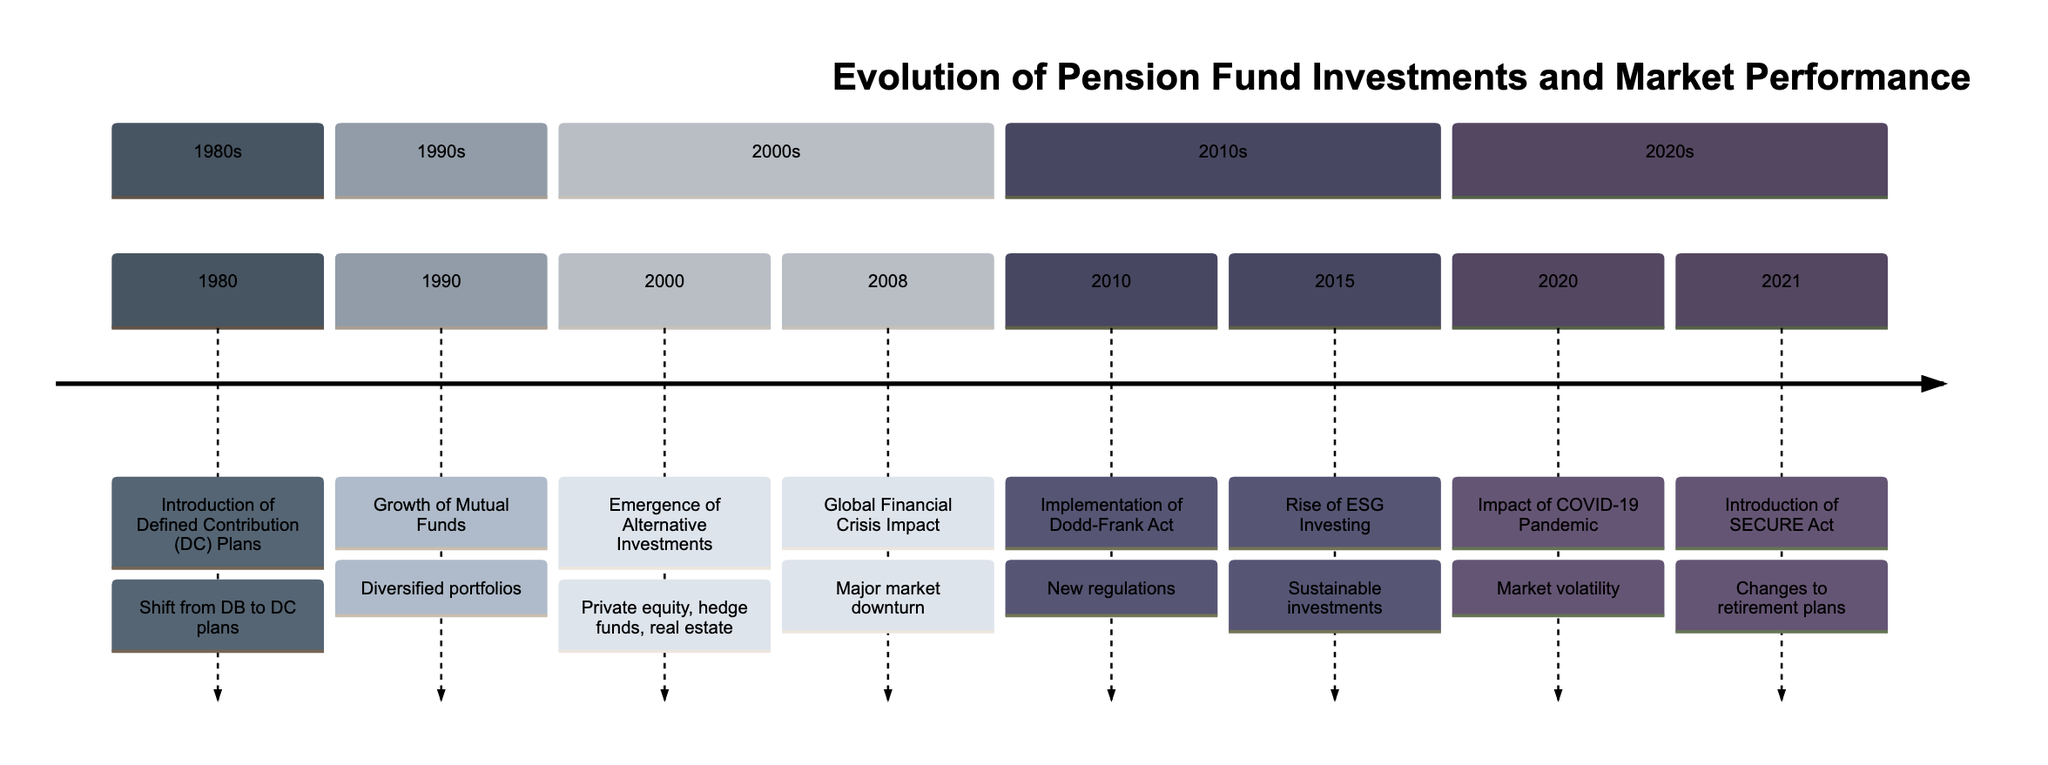What year did the introduction of Defined Contribution plans occur? The diagram clearly indicates that the event "Introduction of Defined Contribution (DC) Plans" occurred in the year 1980. So, by simply locating the year associated with this event, we find the answer.
Answer: 1980 How many events are listed in the 1990s section? By counting the events shown in the 1990s section of the timeline, we find that there is only one event, "Growth of Mutual Funds," making the count easy to determine.
Answer: 1 What was the impact of the Global Financial Crisis on pension funds? The diagram states that the Global Financial Crisis led to a "Major market downturn," which outlines the direct consequence of this event for pension funds. Therefore, we can summarize the impact in this phrase.
Answer: Major market downturn What significant investment approach emerged in 2000? According to the timeline, the event described for the year 2000 is the "Emergence of Alternative Investments." This immediately tells us what approach became significant that year.
Answer: Emergence of Alternative Investments How many times was "impact" mentioned in the timeline? To determine the frequency of the term "impact," we can review the events listed in the timeline. It appears in two events: one is "Global Financial Crisis Impact" and the other is "Impact of COVID-19 Pandemic." Thus, we simply count these occurrences.
Answer: 2 What event occurred after the Rise of ESG Investing? Referring to the timeline, "Impact of COVID-19 Pandemic" is the event that follows "Rise of ESG Investing," as events are listed chronologically from earliest to latest. This helps us identify the subsequent event directly.
Answer: Impact of COVID-19 Pandemic Which act was implemented in 2010? The diagram specifies "Implementation of Dodd-Frank Act" as the event for the year 2010, allowing us to simply find the corresponding act associated with that year.
Answer: Dodd-Frank Act What types of investments increased for pension funds in 2000? The document states that in 2000, there was "Increased allocation of pension funds to alternative investments like private equity, hedge funds, and real estate." By summarizing this information, we can list the types of investments involved.
Answer: Alternative investments Which criteria gained popularity among pension funds in 2015? The timeline indicates "Rise of ESG Investing" for the year 2015, which entails the growing interest in Environmental, Social, and Governance criteria among pension funds. This allows us to identify the specific criteria that gained traction.
Answer: ESG criteria 